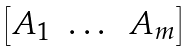Convert formula to latex. <formula><loc_0><loc_0><loc_500><loc_500>\begin{bmatrix} A _ { 1 } & \dots & A _ { m } \end{bmatrix}</formula> 